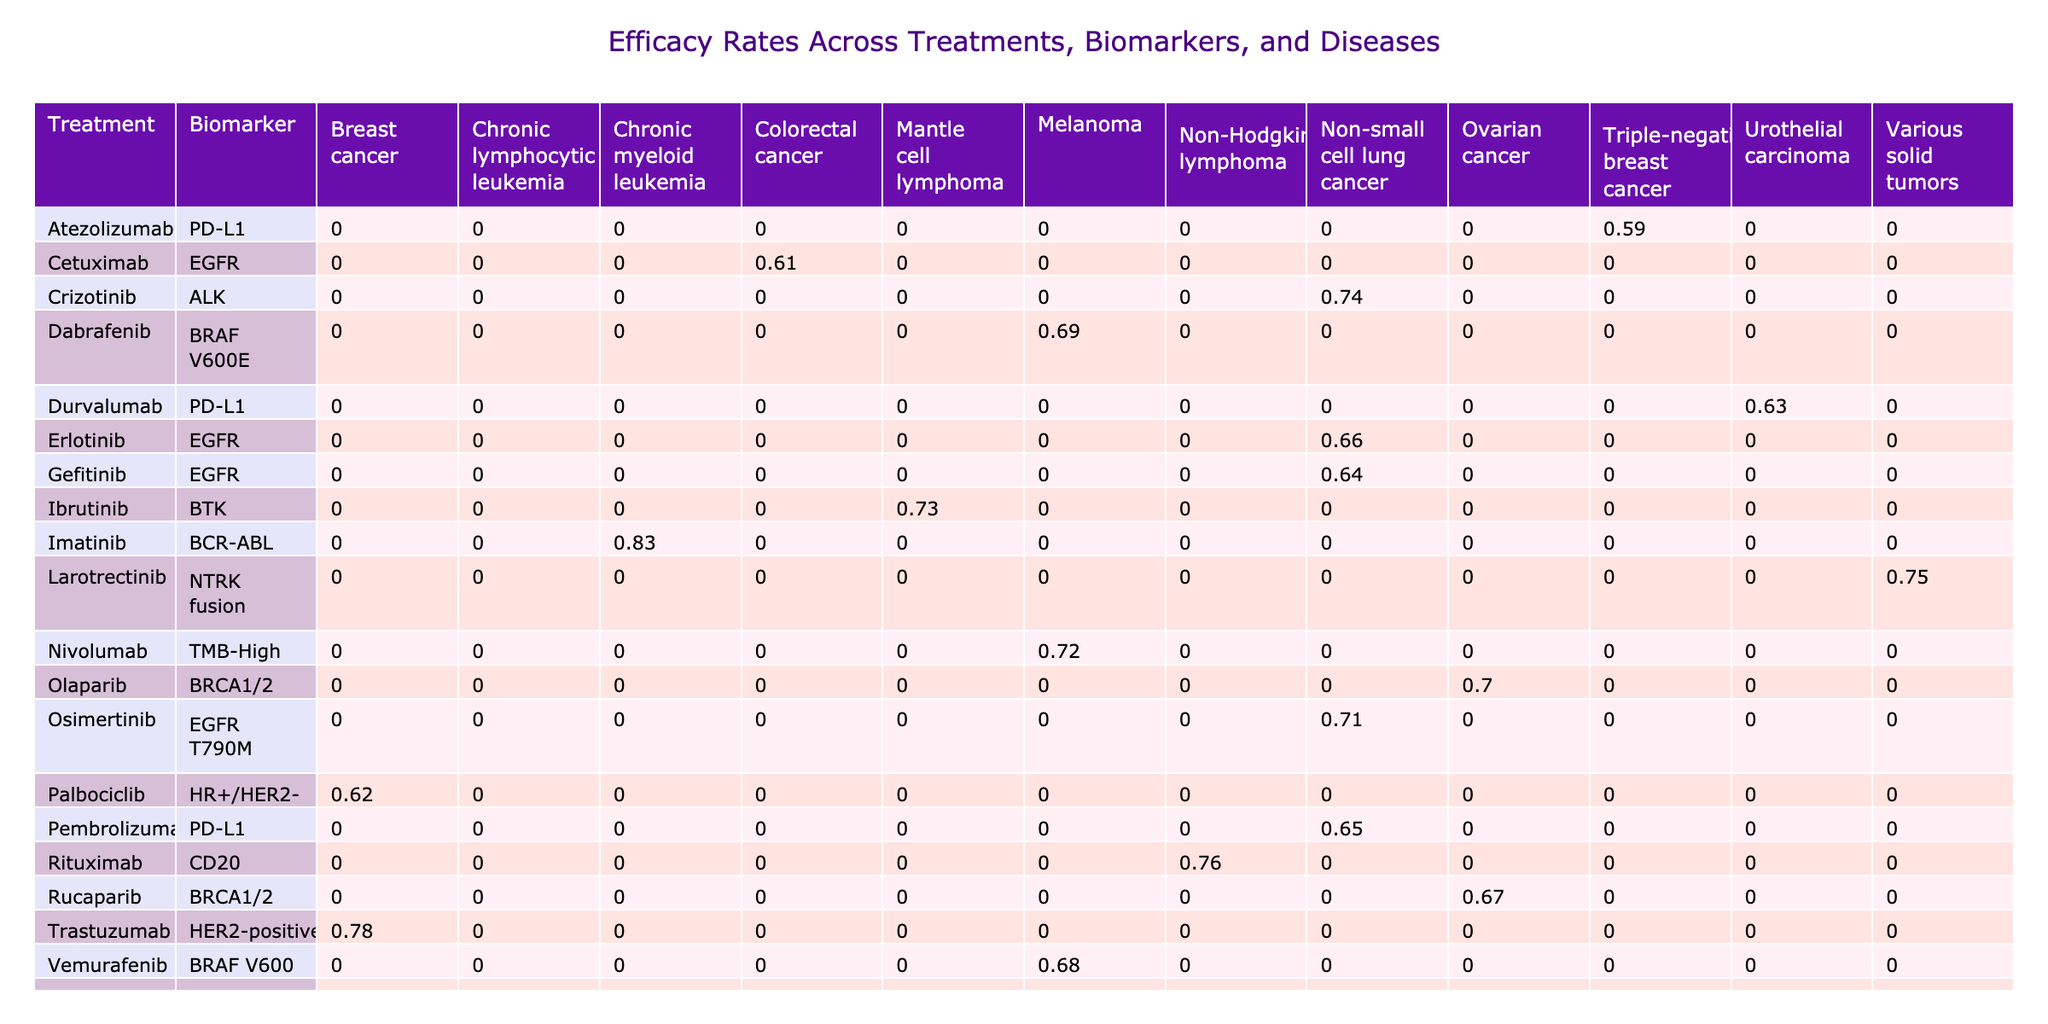What is the efficacy rate of Trastuzumab for Breast cancer? The table shows that the efficacy rate for Trastuzumab in the Breast cancer column is 0.78.
Answer: 0.78 Which treatment has the highest efficacy rate for Chronic myeloid leukemia? Imatinib has the highest efficacy rate for Chronic myeloid leukemia, which is 0.83, compared to other treatments in that disease category.
Answer: Imatinib Is the efficacy rate of Osimertinib higher than that of Gefitinib for Non-small cell lung cancer? The efficacy rate for Osimertinib is 0.71 and for Gefitinib is 0.64. Since 0.71 is greater than 0.64, Osimertinib has a higher efficacy rate.
Answer: Yes What is the average efficacy rate for treatments targeting the PD-L1 biomarker? The efficacy rates for PD-L1 treatments are 0.65 (Pembrolizumab), 0.63 (Durvalumab), and 0.59 (Atezolizumab). Summing these gives 0.65 + 0.63 + 0.59 = 1.87. Dividing by the 3 treatments gives an average of 1.87 / 3 = 0.6233, rounding to two decimal points gives 0.62.
Answer: 0.62 Which disease has the lowest efficacy rate reported in the table, and what is that rate? By examining the efficacy rates across all diseases, the lowest reported efficacy rate is for Triple-negative breast cancer with a rate of 0.59 from Atezolizumab.
Answer: 0.59 Are there any treatments that have an efficacy rate of 0.80 or higher? Yes, Imatinib for Chronic myeloid leukemia and Venetoclax for Chronic lymphocytic leukemia both have efficacy rates of 0.83 and 0.80 respectively.
Answer: Yes What is the difference in efficacy rates between the best and the worst treatments in the table? The best treatment is Imatinib with an efficacy rate of 0.83, and the worst treatment in the table is Atezolizumab with an efficacy rate of 0.59. The difference is 0.83 - 0.59 = 0.24.
Answer: 0.24 Identify the treatment with the second highest patient count and its corresponding efficacy rate. The treatment with the second highest patient count is Rituximab (280 patients) with an efficacy rate of 0.76.
Answer: Rituximab, 0.76 How many treatments have an efficacy rate greater than 0.70? Upon reviewing the table, the treatments with an efficacy rate greater than 0.70 are Imatinib (0.83), Venetoclax (0.80), Trastuzumab (0.78), Rituximab (0.76), Osimertinib (0.71), and Nivolumab (0.72). This counts to 6 treatments.
Answer: 6 